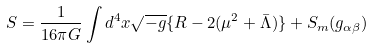<formula> <loc_0><loc_0><loc_500><loc_500>S = \frac { 1 } { 1 6 \pi G } \int d ^ { 4 } x \sqrt { - g } \{ R - 2 ( \mu ^ { 2 } + \bar { \Lambda } ) \} + S _ { m } ( g _ { \alpha \beta } )</formula> 